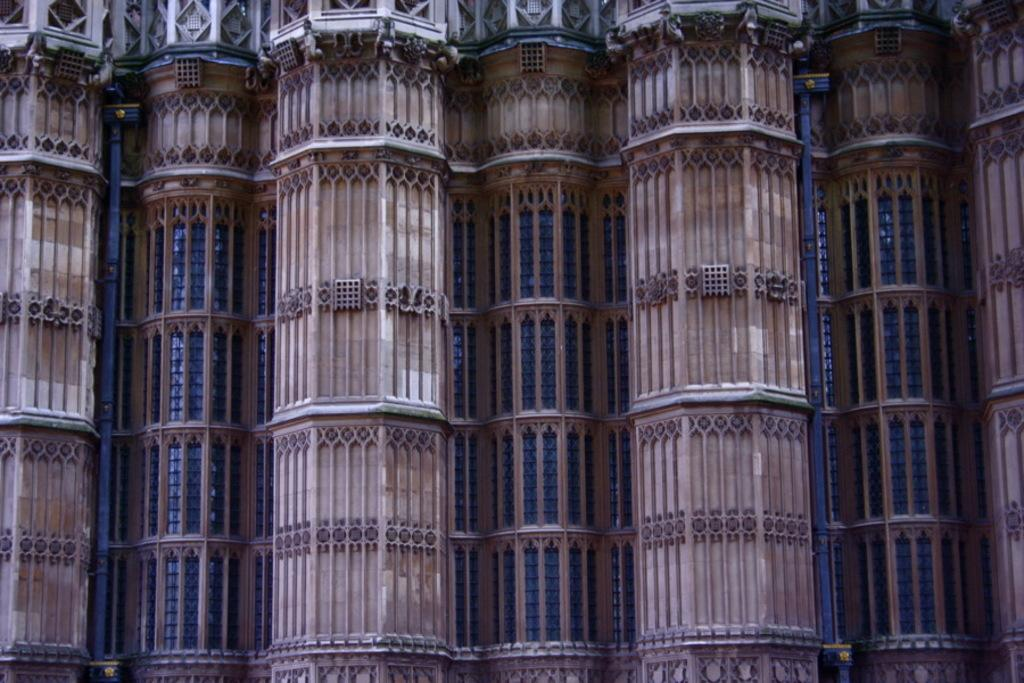What is the main subject of the image? The main subject of the image is a building. Can you describe the building in the image? The building has multiple windows. What type of boot is being worn by the person in the scene? There is no person or scene present in the image; it only features a building with multiple windows. 